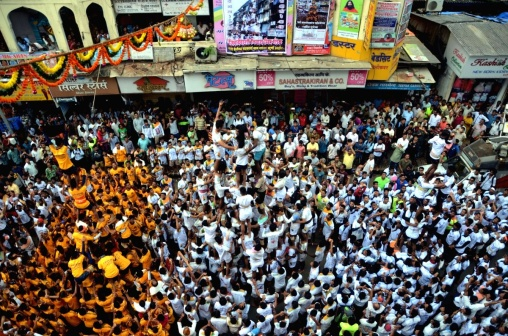What do you see happening in this image? The image captures a vibrant scene on a bustling street, teeming with a large crowd of people. The majority of the individuals are donned in white and orange attire, adding a splash of color to the scene. They are actively participating in what appears to be a parade or celebration, as indicated by the banners and signs they are enthusiastically holding up.

The street itself is a hive of activity, lined with a variety of shops and buildings that add to the urban backdrop of the image. Above the crowd, colorful decorations are suspended, contributing to the festive atmosphere.

The relative positions of the objects and people suggest a well-organized event. The crowd is gathered in the center of the street, allowing for a clear view of the shops and buildings on either side. The banners and signs are held high, making them visible above the sea of people.

Despite the image being rich in detail, there is no discernible text present. The focus is purely on the lively gathering and the urban setting in which it is taking place. The image is a snapshot of a moment of collective joy and celebration, captured in the heart of a busy city street. 